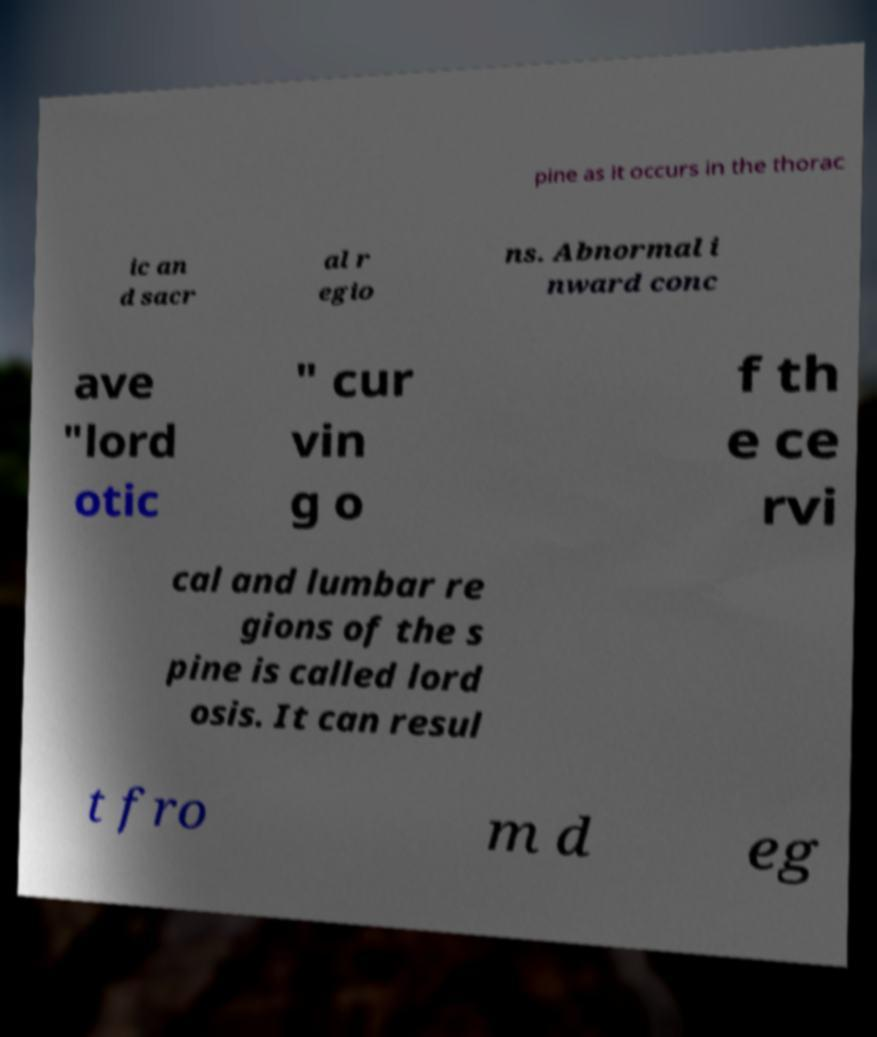Can you read and provide the text displayed in the image?This photo seems to have some interesting text. Can you extract and type it out for me? pine as it occurs in the thorac ic an d sacr al r egio ns. Abnormal i nward conc ave "lord otic " cur vin g o f th e ce rvi cal and lumbar re gions of the s pine is called lord osis. It can resul t fro m d eg 